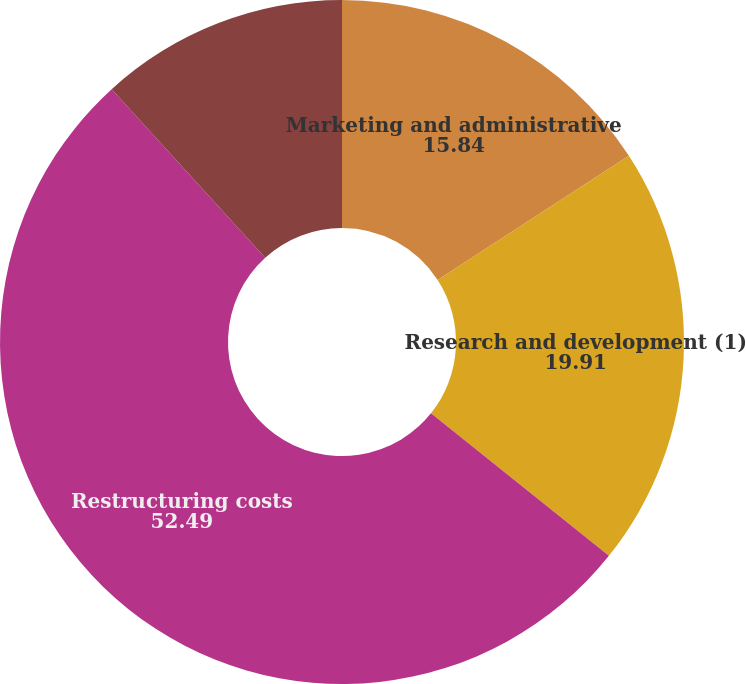Convert chart. <chart><loc_0><loc_0><loc_500><loc_500><pie_chart><fcel>Marketing and administrative<fcel>Research and development (1)<fcel>Restructuring costs<fcel>Equity income from affiliates<nl><fcel>15.84%<fcel>19.91%<fcel>52.49%<fcel>11.76%<nl></chart> 